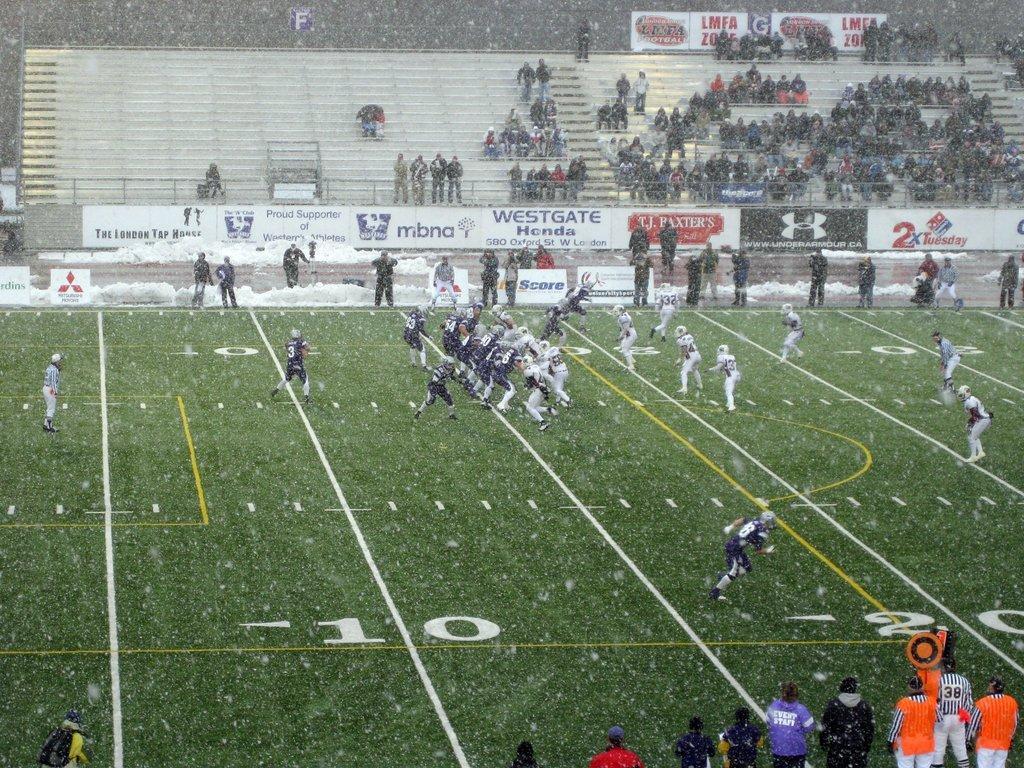Can you describe this image briefly? In this image I can see few people are sitting on stairs and few players in the ground. They are wearing different color dresses. I can see different banners and the snow fall. 